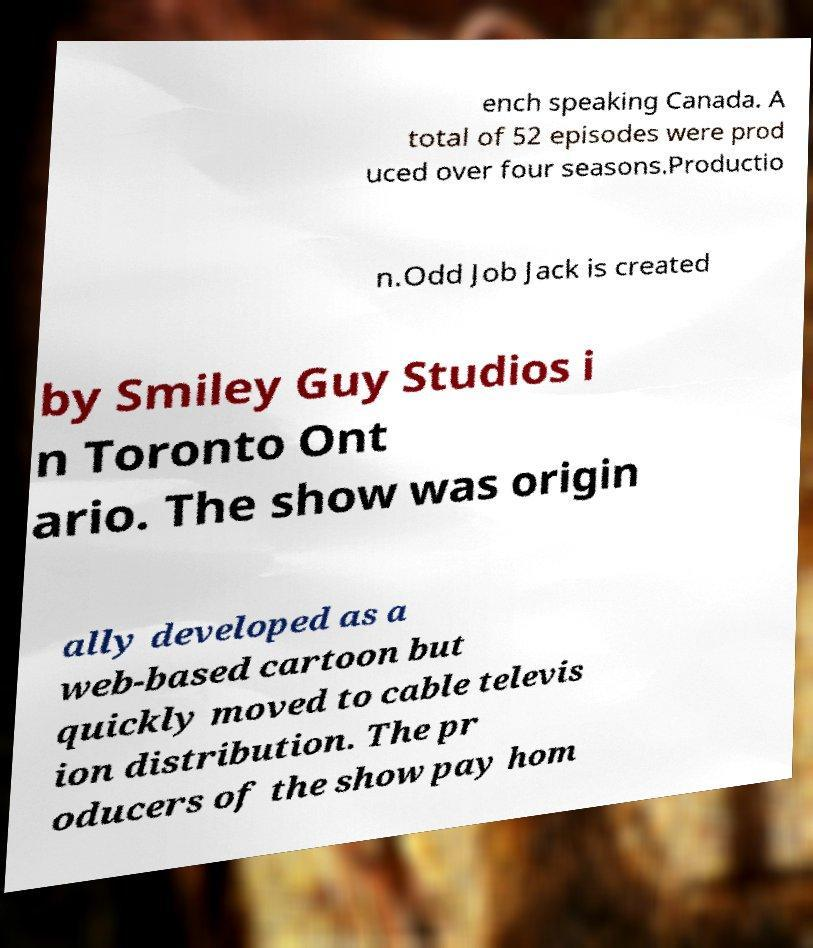Could you extract and type out the text from this image? ench speaking Canada. A total of 52 episodes were prod uced over four seasons.Productio n.Odd Job Jack is created by Smiley Guy Studios i n Toronto Ont ario. The show was origin ally developed as a web-based cartoon but quickly moved to cable televis ion distribution. The pr oducers of the show pay hom 